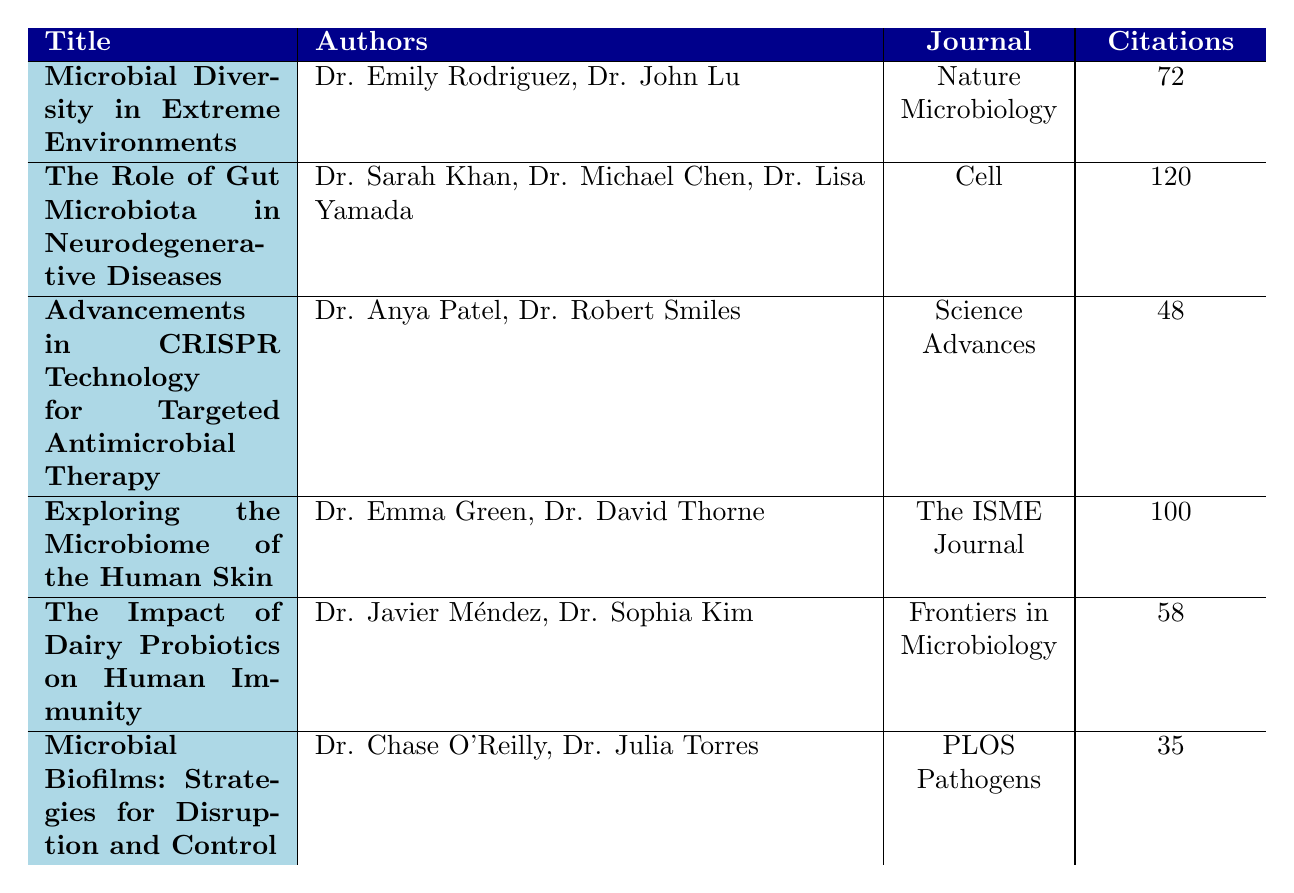What is the title of the paper with the highest number of citations? The paper with the highest number of citations has 120 citations, which belongs to the title "The Role of Gut Microbiota in Neurodegenerative Diseases."
Answer: The Role of Gut Microbiota in Neurodegenerative Diseases How many authors contributed to the paper titled "Microbial Diversity in Extreme Environments"? The paper titled "Microbial Diversity in Extreme Environments" has two authors: Dr. Emily Rodriguez and Dr. John Lu.
Answer: 2 Which journal published the paper titled "Advancements in CRISPR Technology for Targeted Antimicrobial Therapy"? The paper titled "Advancements in CRISPR Technology for Targeted Antimicrobial Therapy" was published in the journal Science Advances.
Answer: Science Advances What is the impact factor of the journal that published "Exploring the Microbiome of the Human Skin"? The journal that published "Exploring the Microbiome of the Human Skin," which is The ISME Journal, has an impact factor of 12.1.
Answer: 12.1 What is the average number of citations for all papers listed in the table? The total number of citations from all papers is 72 + 120 + 48 + 100 + 58 + 35 = 433. Since there are 6 papers, the average number of citations is 433 / 6 = 72.17.
Answer: 72.17 Is the paper "The Impact of Dairy Probiotics on Human Immunity" authored by more than two people? This paper is authored by Dr. Javier Méndez and Dr. Sophia Kim, totaling to 2 authors, which is not more than two.
Answer: No Which paper has the lowest impact factor? The paper with the lowest impact factor is "The Impact of Dairy Probiotics on Human Immunity," which has an impact factor of 6.6.
Answer: The Impact of Dairy Probiotics on Human Immunity How many citations does the paper "Microbial Biofilms: Strategies for Disruption and Control" have compared to the paper "Advancements in CRISPR Technology for Targeted Antimicrobial Therapy"? "Microbial Biofilms: Strategies for Disruption and Control" has 35 citations, while "Advancements in CRISPR Technology for Targeted Antimicrobial Therapy" has 48 citations. The difference in citations is 48 - 35 = 13.
Answer: 13 What is the publication date of the paper with the highest impact factor? The paper with the highest impact factor is "Microbial Diversity in Extreme Environments," published on April 15, 2023.
Answer: April 15, 2023 Which authors wrote the paper that explores microbiota's influence on neurodegenerative diseases? The authors of the paper titled "The Role of Gut Microbiota in Neurodegenerative Diseases" are Dr. Sarah Khan, Dr. Michael Chen, and Dr. Lisa Yamada.
Answer: Dr. Sarah Khan, Dr. Michael Chen, Dr. Lisa Yamada 